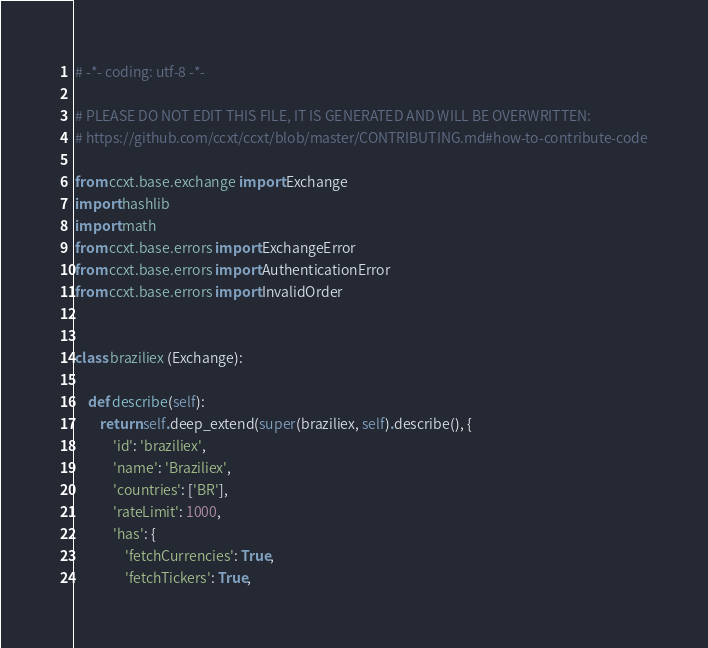<code> <loc_0><loc_0><loc_500><loc_500><_Python_># -*- coding: utf-8 -*-

# PLEASE DO NOT EDIT THIS FILE, IT IS GENERATED AND WILL BE OVERWRITTEN:
# https://github.com/ccxt/ccxt/blob/master/CONTRIBUTING.md#how-to-contribute-code

from ccxt.base.exchange import Exchange
import hashlib
import math
from ccxt.base.errors import ExchangeError
from ccxt.base.errors import AuthenticationError
from ccxt.base.errors import InvalidOrder


class braziliex (Exchange):

    def describe(self):
        return self.deep_extend(super(braziliex, self).describe(), {
            'id': 'braziliex',
            'name': 'Braziliex',
            'countries': ['BR'],
            'rateLimit': 1000,
            'has': {
                'fetchCurrencies': True,
                'fetchTickers': True,</code> 